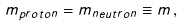Convert formula to latex. <formula><loc_0><loc_0><loc_500><loc_500>m _ { p r o t o n } = m _ { n e u t r o n } \equiv m \, ,</formula> 